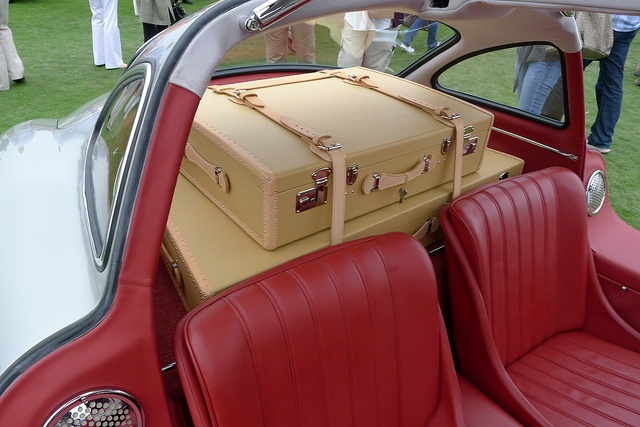Describe the objects in this image and their specific colors. I can see car in maroon, brown, darkgray, and lightgray tones, chair in darkgray, maroon, and brown tones, chair in darkgray, maroon, brown, and black tones, suitcase in darkgray, olive, and tan tones, and suitcase in darkgray, tan, gray, olive, and maroon tones in this image. 